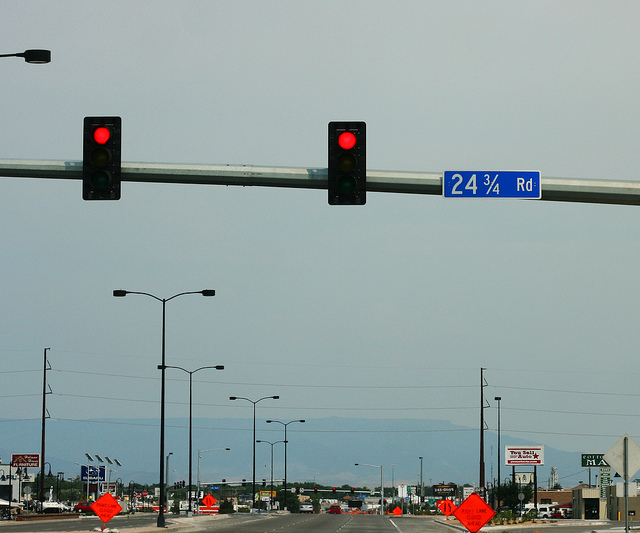Read and extract the text from this image. 2 4 Rd nLA 3/4 